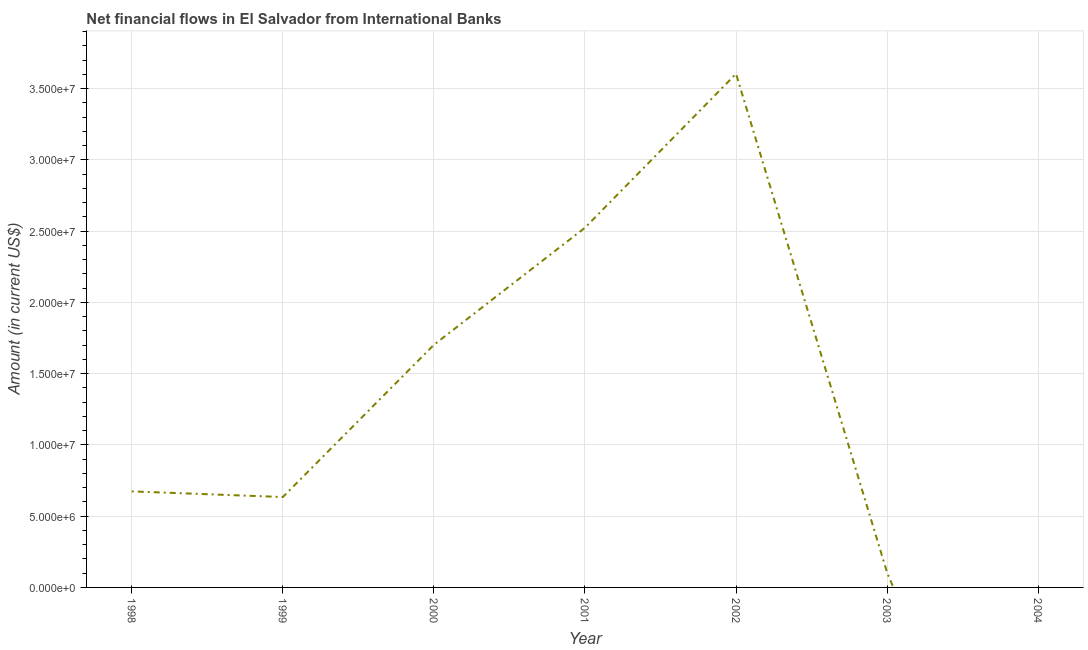What is the net financial flows from ibrd in 1998?
Your answer should be very brief. 6.74e+06. Across all years, what is the maximum net financial flows from ibrd?
Ensure brevity in your answer.  3.60e+07. Across all years, what is the minimum net financial flows from ibrd?
Ensure brevity in your answer.  0. In which year was the net financial flows from ibrd maximum?
Your answer should be very brief. 2002. What is the sum of the net financial flows from ibrd?
Your answer should be very brief. 9.24e+07. What is the difference between the net financial flows from ibrd in 1998 and 2003?
Your response must be concise. 5.70e+06. What is the average net financial flows from ibrd per year?
Ensure brevity in your answer.  1.32e+07. What is the median net financial flows from ibrd?
Make the answer very short. 6.74e+06. In how many years, is the net financial flows from ibrd greater than 14000000 US$?
Give a very brief answer. 3. What is the ratio of the net financial flows from ibrd in 1999 to that in 2002?
Your answer should be compact. 0.18. Is the net financial flows from ibrd in 2001 less than that in 2003?
Provide a succinct answer. No. Is the difference between the net financial flows from ibrd in 1999 and 2003 greater than the difference between any two years?
Offer a terse response. No. What is the difference between the highest and the second highest net financial flows from ibrd?
Give a very brief answer. 1.08e+07. What is the difference between the highest and the lowest net financial flows from ibrd?
Make the answer very short. 3.60e+07. In how many years, is the net financial flows from ibrd greater than the average net financial flows from ibrd taken over all years?
Offer a terse response. 3. Does the net financial flows from ibrd monotonically increase over the years?
Give a very brief answer. No. What is the title of the graph?
Give a very brief answer. Net financial flows in El Salvador from International Banks. What is the Amount (in current US$) in 1998?
Offer a terse response. 6.74e+06. What is the Amount (in current US$) in 1999?
Ensure brevity in your answer.  6.34e+06. What is the Amount (in current US$) in 2000?
Offer a terse response. 1.70e+07. What is the Amount (in current US$) of 2001?
Give a very brief answer. 2.52e+07. What is the Amount (in current US$) in 2002?
Your answer should be compact. 3.60e+07. What is the Amount (in current US$) of 2003?
Your answer should be very brief. 1.04e+06. What is the Amount (in current US$) in 2004?
Your response must be concise. 0. What is the difference between the Amount (in current US$) in 1998 and 1999?
Ensure brevity in your answer.  3.96e+05. What is the difference between the Amount (in current US$) in 1998 and 2000?
Provide a succinct answer. -1.03e+07. What is the difference between the Amount (in current US$) in 1998 and 2001?
Ensure brevity in your answer.  -1.85e+07. What is the difference between the Amount (in current US$) in 1998 and 2002?
Provide a succinct answer. -2.93e+07. What is the difference between the Amount (in current US$) in 1998 and 2003?
Provide a short and direct response. 5.70e+06. What is the difference between the Amount (in current US$) in 1999 and 2000?
Make the answer very short. -1.07e+07. What is the difference between the Amount (in current US$) in 1999 and 2001?
Your answer should be compact. -1.89e+07. What is the difference between the Amount (in current US$) in 1999 and 2002?
Your response must be concise. -2.97e+07. What is the difference between the Amount (in current US$) in 1999 and 2003?
Make the answer very short. 5.30e+06. What is the difference between the Amount (in current US$) in 2000 and 2001?
Your answer should be very brief. -8.22e+06. What is the difference between the Amount (in current US$) in 2000 and 2002?
Provide a succinct answer. -1.90e+07. What is the difference between the Amount (in current US$) in 2000 and 2003?
Ensure brevity in your answer.  1.60e+07. What is the difference between the Amount (in current US$) in 2001 and 2002?
Ensure brevity in your answer.  -1.08e+07. What is the difference between the Amount (in current US$) in 2001 and 2003?
Provide a short and direct response. 2.42e+07. What is the difference between the Amount (in current US$) in 2002 and 2003?
Offer a terse response. 3.50e+07. What is the ratio of the Amount (in current US$) in 1998 to that in 1999?
Your answer should be compact. 1.06. What is the ratio of the Amount (in current US$) in 1998 to that in 2000?
Give a very brief answer. 0.4. What is the ratio of the Amount (in current US$) in 1998 to that in 2001?
Ensure brevity in your answer.  0.27. What is the ratio of the Amount (in current US$) in 1998 to that in 2002?
Offer a very short reply. 0.19. What is the ratio of the Amount (in current US$) in 1998 to that in 2003?
Offer a very short reply. 6.46. What is the ratio of the Amount (in current US$) in 1999 to that in 2000?
Your answer should be compact. 0.37. What is the ratio of the Amount (in current US$) in 1999 to that in 2001?
Offer a terse response. 0.25. What is the ratio of the Amount (in current US$) in 1999 to that in 2002?
Keep it short and to the point. 0.18. What is the ratio of the Amount (in current US$) in 1999 to that in 2003?
Your answer should be very brief. 6.08. What is the ratio of the Amount (in current US$) in 2000 to that in 2001?
Give a very brief answer. 0.67. What is the ratio of the Amount (in current US$) in 2000 to that in 2002?
Give a very brief answer. 0.47. What is the ratio of the Amount (in current US$) in 2000 to that in 2003?
Your answer should be compact. 16.31. What is the ratio of the Amount (in current US$) in 2001 to that in 2002?
Your answer should be very brief. 0.7. What is the ratio of the Amount (in current US$) in 2001 to that in 2003?
Provide a succinct answer. 24.18. What is the ratio of the Amount (in current US$) in 2002 to that in 2003?
Provide a short and direct response. 34.53. 